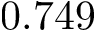Convert formula to latex. <formula><loc_0><loc_0><loc_500><loc_500>0 . 7 4 9</formula> 